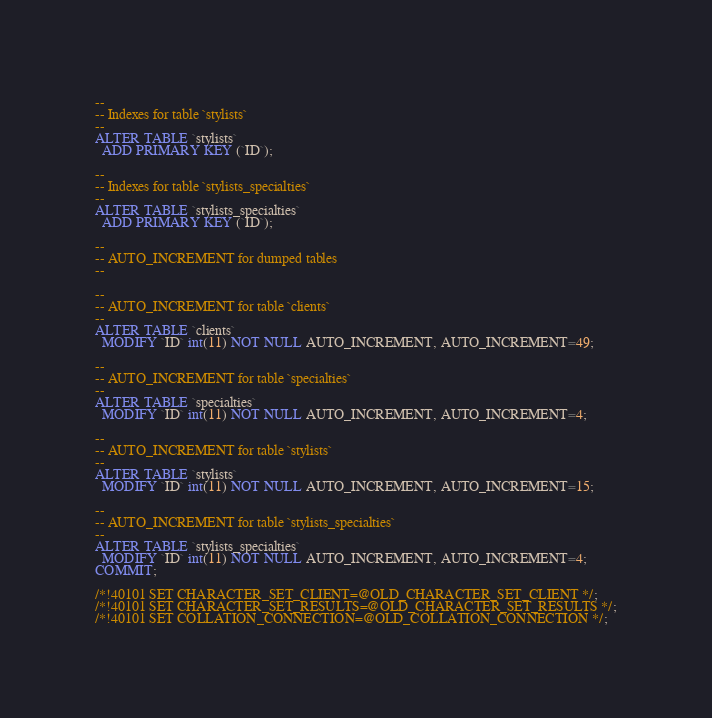<code> <loc_0><loc_0><loc_500><loc_500><_SQL_>
--
-- Indexes for table `stylists`
--
ALTER TABLE `stylists`
  ADD PRIMARY KEY (`ID`);

--
-- Indexes for table `stylists_specialties`
--
ALTER TABLE `stylists_specialties`
  ADD PRIMARY KEY (`ID`);

--
-- AUTO_INCREMENT for dumped tables
--

--
-- AUTO_INCREMENT for table `clients`
--
ALTER TABLE `clients`
  MODIFY `ID` int(11) NOT NULL AUTO_INCREMENT, AUTO_INCREMENT=49;

--
-- AUTO_INCREMENT for table `specialties`
--
ALTER TABLE `specialties`
  MODIFY `ID` int(11) NOT NULL AUTO_INCREMENT, AUTO_INCREMENT=4;

--
-- AUTO_INCREMENT for table `stylists`
--
ALTER TABLE `stylists`
  MODIFY `ID` int(11) NOT NULL AUTO_INCREMENT, AUTO_INCREMENT=15;

--
-- AUTO_INCREMENT for table `stylists_specialties`
--
ALTER TABLE `stylists_specialties`
  MODIFY `ID` int(11) NOT NULL AUTO_INCREMENT, AUTO_INCREMENT=4;
COMMIT;

/*!40101 SET CHARACTER_SET_CLIENT=@OLD_CHARACTER_SET_CLIENT */;
/*!40101 SET CHARACTER_SET_RESULTS=@OLD_CHARACTER_SET_RESULTS */;
/*!40101 SET COLLATION_CONNECTION=@OLD_COLLATION_CONNECTION */;
</code> 